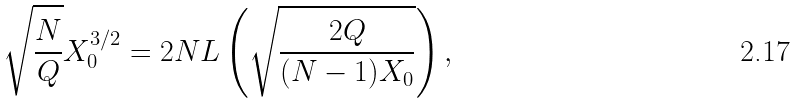<formula> <loc_0><loc_0><loc_500><loc_500>\sqrt { \frac { N } { Q } } X _ { 0 } ^ { 3 / 2 } = 2 N L \left ( \sqrt { \frac { 2 Q } { ( N - 1 ) X _ { 0 } } } \right ) ,</formula> 